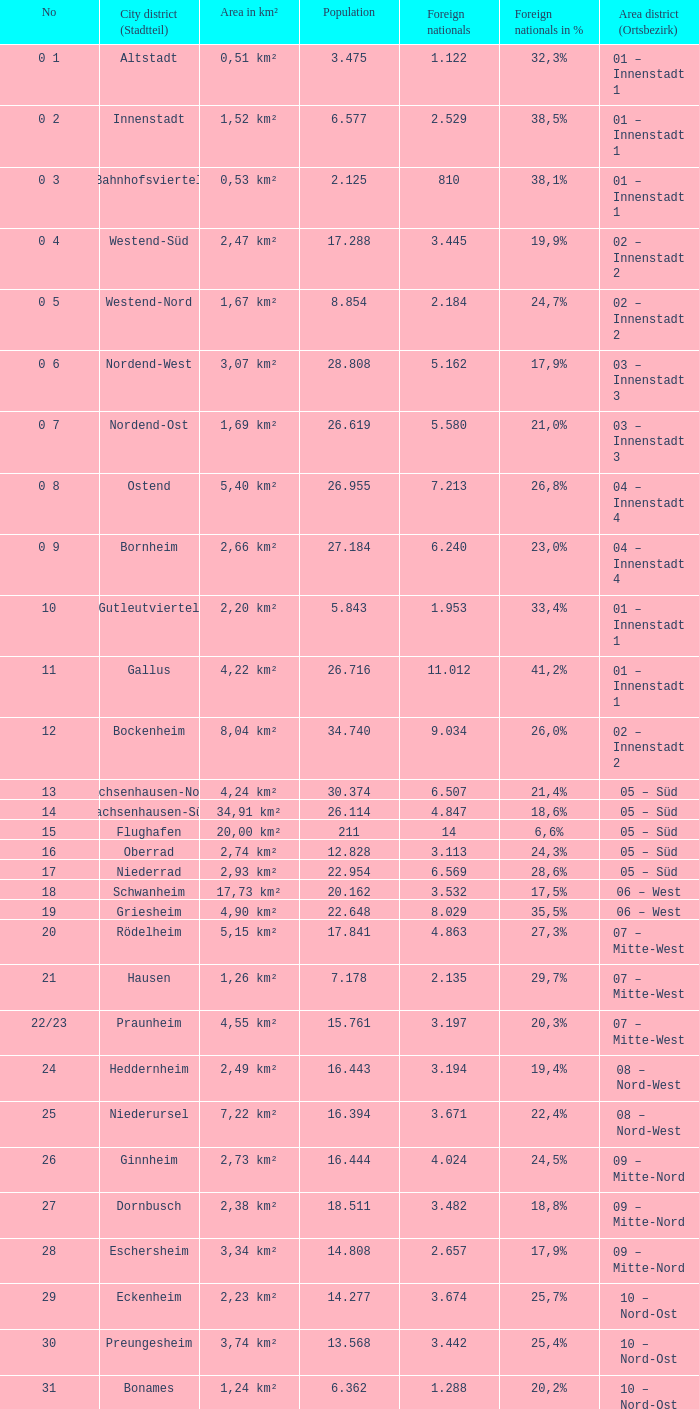In a population of 4.911, what percentage represents the foreign population? 1.0. 